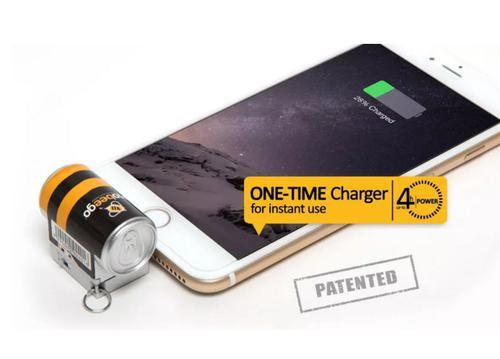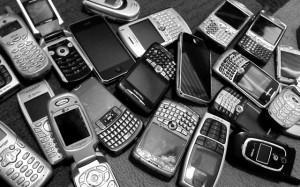The first image is the image on the left, the second image is the image on the right. Assess this claim about the two images: "The left image contains no more than two phones, and the right image shows a messy pile of at least a dozen phones.". Correct or not? Answer yes or no. Yes. The first image is the image on the left, the second image is the image on the right. For the images displayed, is the sentence "In at least one image there is no more than three standing phones that have at least thirteen buttons." factually correct? Answer yes or no. No. 